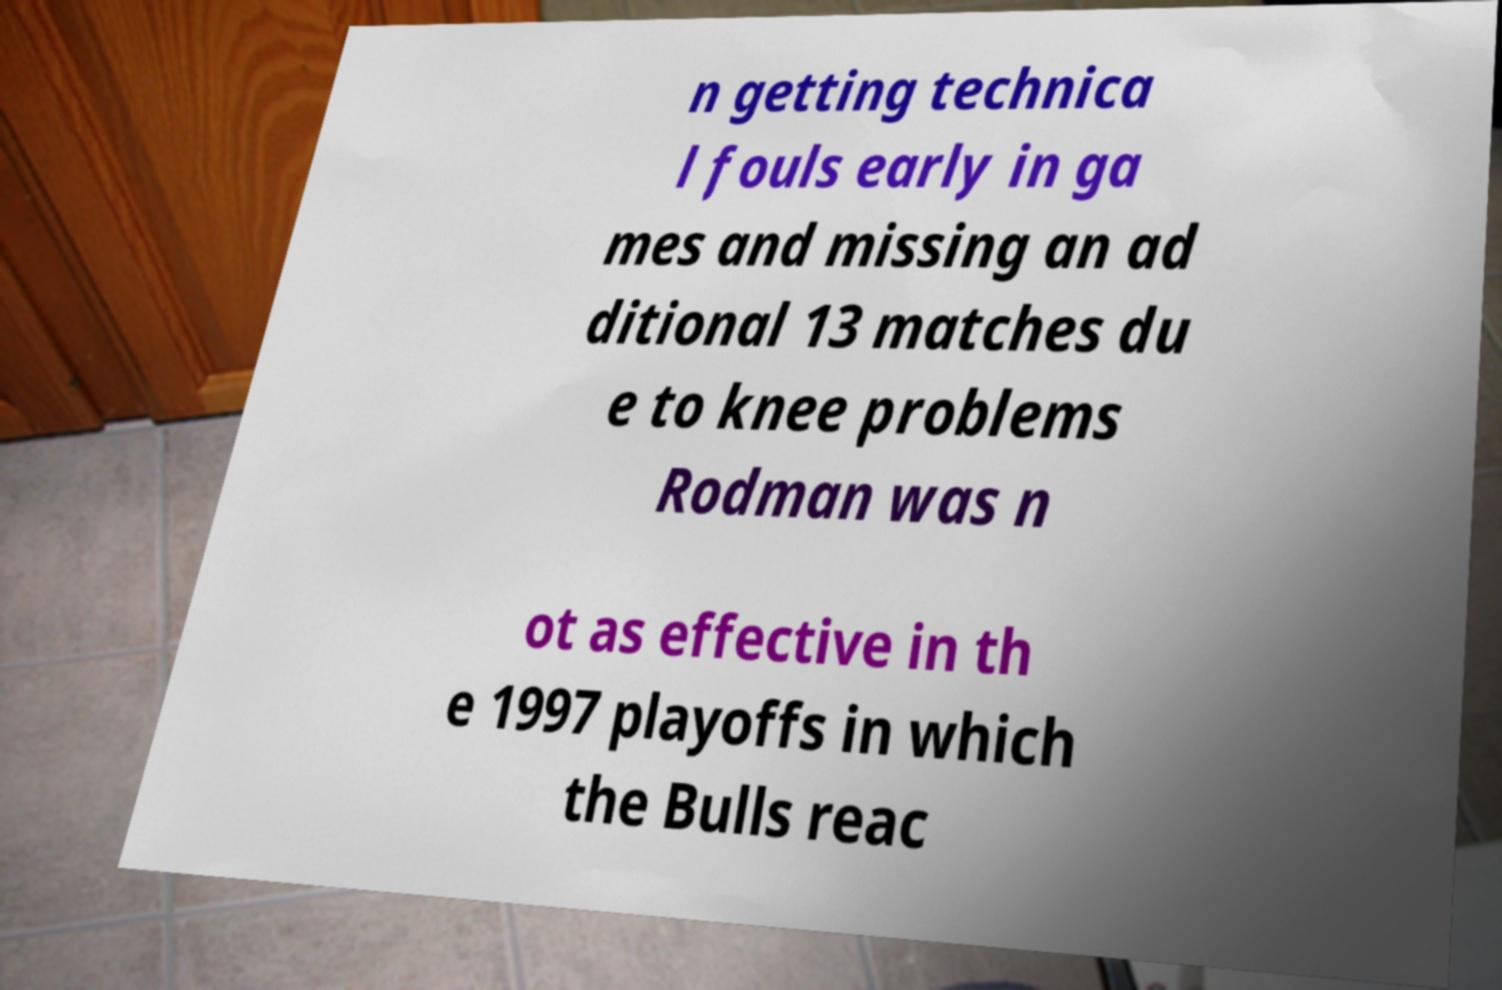What messages or text are displayed in this image? I need them in a readable, typed format. n getting technica l fouls early in ga mes and missing an ad ditional 13 matches du e to knee problems Rodman was n ot as effective in th e 1997 playoffs in which the Bulls reac 